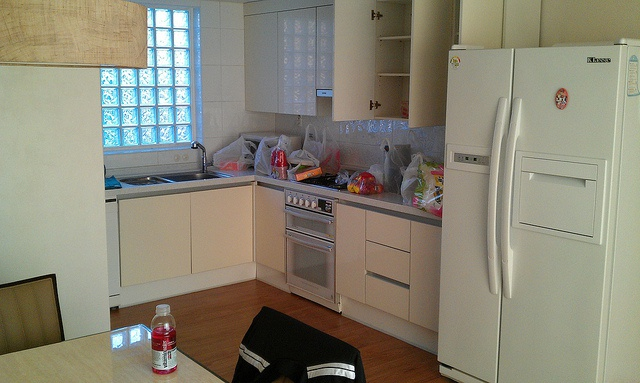Describe the objects in this image and their specific colors. I can see refrigerator in olive, darkgray, gray, and beige tones, dining table in olive and gray tones, chair in olive, black, gray, darkgray, and maroon tones, oven in olive, gray, maroon, and black tones, and chair in olive, black, and gray tones in this image. 